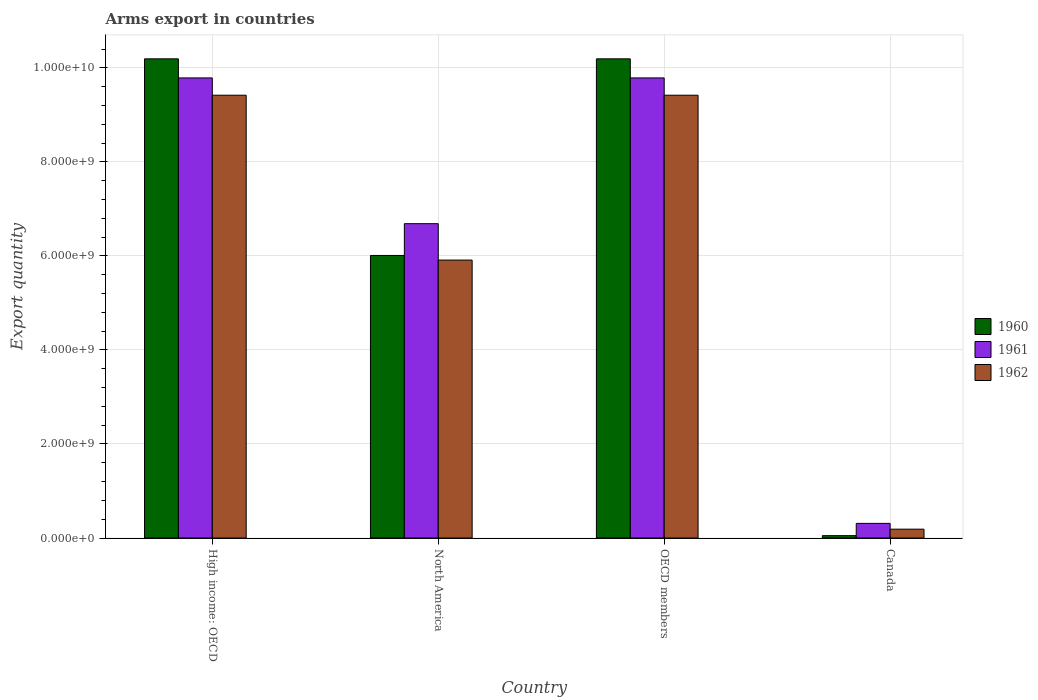How many groups of bars are there?
Ensure brevity in your answer.  4. What is the label of the 1st group of bars from the left?
Give a very brief answer. High income: OECD. What is the total arms export in 1961 in Canada?
Offer a terse response. 3.11e+08. Across all countries, what is the maximum total arms export in 1960?
Your response must be concise. 1.02e+1. Across all countries, what is the minimum total arms export in 1962?
Keep it short and to the point. 1.88e+08. In which country was the total arms export in 1960 maximum?
Your answer should be compact. High income: OECD. What is the total total arms export in 1962 in the graph?
Your answer should be compact. 2.49e+1. What is the difference between the total arms export in 1962 in High income: OECD and that in North America?
Give a very brief answer. 3.51e+09. What is the difference between the total arms export in 1962 in Canada and the total arms export in 1960 in High income: OECD?
Keep it short and to the point. -1.00e+1. What is the average total arms export in 1960 per country?
Make the answer very short. 6.61e+09. What is the difference between the total arms export of/in 1960 and total arms export of/in 1962 in Canada?
Give a very brief answer. -1.38e+08. In how many countries, is the total arms export in 1962 greater than 6000000000?
Provide a short and direct response. 2. What is the ratio of the total arms export in 1961 in Canada to that in OECD members?
Your answer should be compact. 0.03. Is the total arms export in 1960 in Canada less than that in OECD members?
Offer a terse response. Yes. What is the difference between the highest and the second highest total arms export in 1960?
Give a very brief answer. 4.18e+09. What is the difference between the highest and the lowest total arms export in 1960?
Provide a succinct answer. 1.01e+1. In how many countries, is the total arms export in 1962 greater than the average total arms export in 1962 taken over all countries?
Give a very brief answer. 2. Is the sum of the total arms export in 1962 in High income: OECD and OECD members greater than the maximum total arms export in 1961 across all countries?
Ensure brevity in your answer.  Yes. What does the 3rd bar from the left in High income: OECD represents?
Provide a short and direct response. 1962. Is it the case that in every country, the sum of the total arms export in 1962 and total arms export in 1961 is greater than the total arms export in 1960?
Ensure brevity in your answer.  Yes. What is the difference between two consecutive major ticks on the Y-axis?
Provide a succinct answer. 2.00e+09. Are the values on the major ticks of Y-axis written in scientific E-notation?
Your answer should be compact. Yes. Does the graph contain any zero values?
Offer a terse response. No. How many legend labels are there?
Give a very brief answer. 3. What is the title of the graph?
Provide a short and direct response. Arms export in countries. Does "1966" appear as one of the legend labels in the graph?
Make the answer very short. No. What is the label or title of the Y-axis?
Keep it short and to the point. Export quantity. What is the Export quantity of 1960 in High income: OECD?
Your answer should be very brief. 1.02e+1. What is the Export quantity of 1961 in High income: OECD?
Offer a terse response. 9.79e+09. What is the Export quantity in 1962 in High income: OECD?
Your answer should be very brief. 9.42e+09. What is the Export quantity of 1960 in North America?
Provide a short and direct response. 6.01e+09. What is the Export quantity in 1961 in North America?
Your response must be concise. 6.69e+09. What is the Export quantity of 1962 in North America?
Give a very brief answer. 5.91e+09. What is the Export quantity of 1960 in OECD members?
Offer a terse response. 1.02e+1. What is the Export quantity of 1961 in OECD members?
Provide a succinct answer. 9.79e+09. What is the Export quantity in 1962 in OECD members?
Give a very brief answer. 9.42e+09. What is the Export quantity in 1961 in Canada?
Give a very brief answer. 3.11e+08. What is the Export quantity of 1962 in Canada?
Ensure brevity in your answer.  1.88e+08. Across all countries, what is the maximum Export quantity of 1960?
Your answer should be compact. 1.02e+1. Across all countries, what is the maximum Export quantity in 1961?
Ensure brevity in your answer.  9.79e+09. Across all countries, what is the maximum Export quantity of 1962?
Offer a very short reply. 9.42e+09. Across all countries, what is the minimum Export quantity in 1960?
Make the answer very short. 5.00e+07. Across all countries, what is the minimum Export quantity in 1961?
Your response must be concise. 3.11e+08. Across all countries, what is the minimum Export quantity of 1962?
Offer a terse response. 1.88e+08. What is the total Export quantity of 1960 in the graph?
Ensure brevity in your answer.  2.64e+1. What is the total Export quantity in 1961 in the graph?
Keep it short and to the point. 2.66e+1. What is the total Export quantity of 1962 in the graph?
Your answer should be compact. 2.49e+1. What is the difference between the Export quantity in 1960 in High income: OECD and that in North America?
Make the answer very short. 4.18e+09. What is the difference between the Export quantity of 1961 in High income: OECD and that in North America?
Keep it short and to the point. 3.10e+09. What is the difference between the Export quantity of 1962 in High income: OECD and that in North America?
Give a very brief answer. 3.51e+09. What is the difference between the Export quantity in 1960 in High income: OECD and that in OECD members?
Provide a succinct answer. 0. What is the difference between the Export quantity in 1962 in High income: OECD and that in OECD members?
Offer a very short reply. 0. What is the difference between the Export quantity in 1960 in High income: OECD and that in Canada?
Your answer should be very brief. 1.01e+1. What is the difference between the Export quantity in 1961 in High income: OECD and that in Canada?
Provide a succinct answer. 9.48e+09. What is the difference between the Export quantity in 1962 in High income: OECD and that in Canada?
Make the answer very short. 9.23e+09. What is the difference between the Export quantity of 1960 in North America and that in OECD members?
Ensure brevity in your answer.  -4.18e+09. What is the difference between the Export quantity of 1961 in North America and that in OECD members?
Make the answer very short. -3.10e+09. What is the difference between the Export quantity of 1962 in North America and that in OECD members?
Make the answer very short. -3.51e+09. What is the difference between the Export quantity in 1960 in North America and that in Canada?
Provide a succinct answer. 5.96e+09. What is the difference between the Export quantity of 1961 in North America and that in Canada?
Your answer should be compact. 6.38e+09. What is the difference between the Export quantity of 1962 in North America and that in Canada?
Your answer should be very brief. 5.72e+09. What is the difference between the Export quantity in 1960 in OECD members and that in Canada?
Provide a short and direct response. 1.01e+1. What is the difference between the Export quantity in 1961 in OECD members and that in Canada?
Ensure brevity in your answer.  9.48e+09. What is the difference between the Export quantity in 1962 in OECD members and that in Canada?
Keep it short and to the point. 9.23e+09. What is the difference between the Export quantity of 1960 in High income: OECD and the Export quantity of 1961 in North America?
Ensure brevity in your answer.  3.51e+09. What is the difference between the Export quantity in 1960 in High income: OECD and the Export quantity in 1962 in North America?
Ensure brevity in your answer.  4.28e+09. What is the difference between the Export quantity of 1961 in High income: OECD and the Export quantity of 1962 in North America?
Provide a short and direct response. 3.88e+09. What is the difference between the Export quantity in 1960 in High income: OECD and the Export quantity in 1961 in OECD members?
Your answer should be very brief. 4.06e+08. What is the difference between the Export quantity of 1960 in High income: OECD and the Export quantity of 1962 in OECD members?
Keep it short and to the point. 7.74e+08. What is the difference between the Export quantity in 1961 in High income: OECD and the Export quantity in 1962 in OECD members?
Your answer should be very brief. 3.68e+08. What is the difference between the Export quantity of 1960 in High income: OECD and the Export quantity of 1961 in Canada?
Give a very brief answer. 9.88e+09. What is the difference between the Export quantity in 1960 in High income: OECD and the Export quantity in 1962 in Canada?
Your answer should be very brief. 1.00e+1. What is the difference between the Export quantity of 1961 in High income: OECD and the Export quantity of 1962 in Canada?
Ensure brevity in your answer.  9.60e+09. What is the difference between the Export quantity in 1960 in North America and the Export quantity in 1961 in OECD members?
Offer a very short reply. -3.78e+09. What is the difference between the Export quantity of 1960 in North America and the Export quantity of 1962 in OECD members?
Keep it short and to the point. -3.41e+09. What is the difference between the Export quantity in 1961 in North America and the Export quantity in 1962 in OECD members?
Make the answer very short. -2.73e+09. What is the difference between the Export quantity in 1960 in North America and the Export quantity in 1961 in Canada?
Provide a short and direct response. 5.70e+09. What is the difference between the Export quantity of 1960 in North America and the Export quantity of 1962 in Canada?
Your answer should be very brief. 5.82e+09. What is the difference between the Export quantity of 1961 in North America and the Export quantity of 1962 in Canada?
Your answer should be very brief. 6.50e+09. What is the difference between the Export quantity of 1960 in OECD members and the Export quantity of 1961 in Canada?
Give a very brief answer. 9.88e+09. What is the difference between the Export quantity of 1960 in OECD members and the Export quantity of 1962 in Canada?
Provide a succinct answer. 1.00e+1. What is the difference between the Export quantity of 1961 in OECD members and the Export quantity of 1962 in Canada?
Provide a short and direct response. 9.60e+09. What is the average Export quantity in 1960 per country?
Ensure brevity in your answer.  6.61e+09. What is the average Export quantity of 1961 per country?
Ensure brevity in your answer.  6.64e+09. What is the average Export quantity in 1962 per country?
Give a very brief answer. 6.24e+09. What is the difference between the Export quantity of 1960 and Export quantity of 1961 in High income: OECD?
Your answer should be compact. 4.06e+08. What is the difference between the Export quantity of 1960 and Export quantity of 1962 in High income: OECD?
Your answer should be very brief. 7.74e+08. What is the difference between the Export quantity of 1961 and Export quantity of 1962 in High income: OECD?
Ensure brevity in your answer.  3.68e+08. What is the difference between the Export quantity in 1960 and Export quantity in 1961 in North America?
Provide a succinct answer. -6.76e+08. What is the difference between the Export quantity of 1960 and Export quantity of 1962 in North America?
Your response must be concise. 9.80e+07. What is the difference between the Export quantity of 1961 and Export quantity of 1962 in North America?
Ensure brevity in your answer.  7.74e+08. What is the difference between the Export quantity of 1960 and Export quantity of 1961 in OECD members?
Offer a terse response. 4.06e+08. What is the difference between the Export quantity of 1960 and Export quantity of 1962 in OECD members?
Ensure brevity in your answer.  7.74e+08. What is the difference between the Export quantity of 1961 and Export quantity of 1962 in OECD members?
Your answer should be compact. 3.68e+08. What is the difference between the Export quantity in 1960 and Export quantity in 1961 in Canada?
Make the answer very short. -2.61e+08. What is the difference between the Export quantity of 1960 and Export quantity of 1962 in Canada?
Offer a very short reply. -1.38e+08. What is the difference between the Export quantity of 1961 and Export quantity of 1962 in Canada?
Provide a succinct answer. 1.23e+08. What is the ratio of the Export quantity of 1960 in High income: OECD to that in North America?
Keep it short and to the point. 1.7. What is the ratio of the Export quantity in 1961 in High income: OECD to that in North America?
Provide a short and direct response. 1.46. What is the ratio of the Export quantity of 1962 in High income: OECD to that in North America?
Offer a terse response. 1.59. What is the ratio of the Export quantity of 1960 in High income: OECD to that in OECD members?
Provide a short and direct response. 1. What is the ratio of the Export quantity of 1962 in High income: OECD to that in OECD members?
Your answer should be compact. 1. What is the ratio of the Export quantity of 1960 in High income: OECD to that in Canada?
Give a very brief answer. 203.88. What is the ratio of the Export quantity of 1961 in High income: OECD to that in Canada?
Your answer should be compact. 31.47. What is the ratio of the Export quantity in 1962 in High income: OECD to that in Canada?
Your answer should be very brief. 50.11. What is the ratio of the Export quantity of 1960 in North America to that in OECD members?
Your answer should be very brief. 0.59. What is the ratio of the Export quantity of 1961 in North America to that in OECD members?
Your answer should be very brief. 0.68. What is the ratio of the Export quantity in 1962 in North America to that in OECD members?
Make the answer very short. 0.63. What is the ratio of the Export quantity in 1960 in North America to that in Canada?
Provide a succinct answer. 120.22. What is the ratio of the Export quantity of 1961 in North America to that in Canada?
Offer a terse response. 21.5. What is the ratio of the Export quantity in 1962 in North America to that in Canada?
Provide a succinct answer. 31.45. What is the ratio of the Export quantity in 1960 in OECD members to that in Canada?
Ensure brevity in your answer.  203.88. What is the ratio of the Export quantity of 1961 in OECD members to that in Canada?
Your answer should be compact. 31.47. What is the ratio of the Export quantity of 1962 in OECD members to that in Canada?
Your answer should be compact. 50.11. What is the difference between the highest and the second highest Export quantity in 1960?
Make the answer very short. 0. What is the difference between the highest and the second highest Export quantity of 1962?
Give a very brief answer. 0. What is the difference between the highest and the lowest Export quantity of 1960?
Your answer should be very brief. 1.01e+1. What is the difference between the highest and the lowest Export quantity of 1961?
Ensure brevity in your answer.  9.48e+09. What is the difference between the highest and the lowest Export quantity of 1962?
Offer a very short reply. 9.23e+09. 